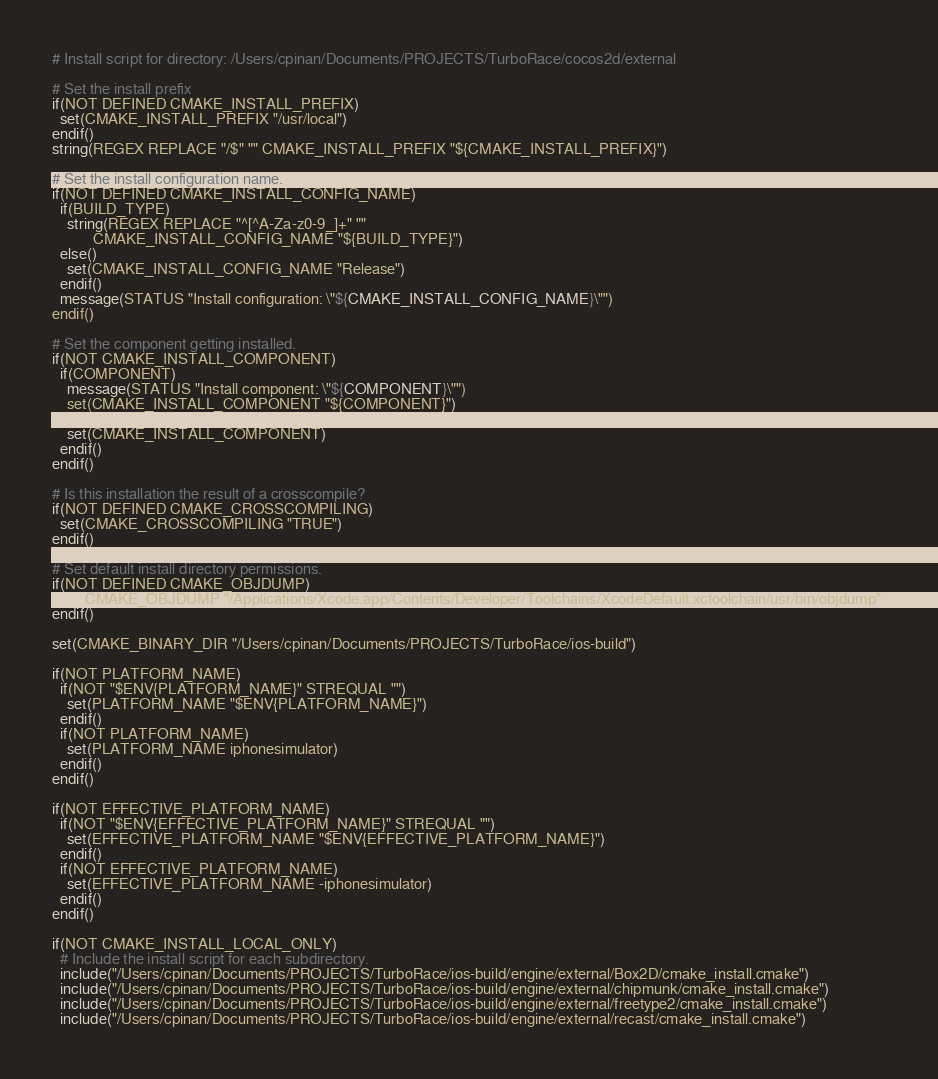Convert code to text. <code><loc_0><loc_0><loc_500><loc_500><_CMake_># Install script for directory: /Users/cpinan/Documents/PROJECTS/TurboRace/cocos2d/external

# Set the install prefix
if(NOT DEFINED CMAKE_INSTALL_PREFIX)
  set(CMAKE_INSTALL_PREFIX "/usr/local")
endif()
string(REGEX REPLACE "/$" "" CMAKE_INSTALL_PREFIX "${CMAKE_INSTALL_PREFIX}")

# Set the install configuration name.
if(NOT DEFINED CMAKE_INSTALL_CONFIG_NAME)
  if(BUILD_TYPE)
    string(REGEX REPLACE "^[^A-Za-z0-9_]+" ""
           CMAKE_INSTALL_CONFIG_NAME "${BUILD_TYPE}")
  else()
    set(CMAKE_INSTALL_CONFIG_NAME "Release")
  endif()
  message(STATUS "Install configuration: \"${CMAKE_INSTALL_CONFIG_NAME}\"")
endif()

# Set the component getting installed.
if(NOT CMAKE_INSTALL_COMPONENT)
  if(COMPONENT)
    message(STATUS "Install component: \"${COMPONENT}\"")
    set(CMAKE_INSTALL_COMPONENT "${COMPONENT}")
  else()
    set(CMAKE_INSTALL_COMPONENT)
  endif()
endif()

# Is this installation the result of a crosscompile?
if(NOT DEFINED CMAKE_CROSSCOMPILING)
  set(CMAKE_CROSSCOMPILING "TRUE")
endif()

# Set default install directory permissions.
if(NOT DEFINED CMAKE_OBJDUMP)
  set(CMAKE_OBJDUMP "/Applications/Xcode.app/Contents/Developer/Toolchains/XcodeDefault.xctoolchain/usr/bin/objdump")
endif()

set(CMAKE_BINARY_DIR "/Users/cpinan/Documents/PROJECTS/TurboRace/ios-build")

if(NOT PLATFORM_NAME)
  if(NOT "$ENV{PLATFORM_NAME}" STREQUAL "")
    set(PLATFORM_NAME "$ENV{PLATFORM_NAME}")
  endif()
  if(NOT PLATFORM_NAME)
    set(PLATFORM_NAME iphonesimulator)
  endif()
endif()

if(NOT EFFECTIVE_PLATFORM_NAME)
  if(NOT "$ENV{EFFECTIVE_PLATFORM_NAME}" STREQUAL "")
    set(EFFECTIVE_PLATFORM_NAME "$ENV{EFFECTIVE_PLATFORM_NAME}")
  endif()
  if(NOT EFFECTIVE_PLATFORM_NAME)
    set(EFFECTIVE_PLATFORM_NAME -iphonesimulator)
  endif()
endif()

if(NOT CMAKE_INSTALL_LOCAL_ONLY)
  # Include the install script for each subdirectory.
  include("/Users/cpinan/Documents/PROJECTS/TurboRace/ios-build/engine/external/Box2D/cmake_install.cmake")
  include("/Users/cpinan/Documents/PROJECTS/TurboRace/ios-build/engine/external/chipmunk/cmake_install.cmake")
  include("/Users/cpinan/Documents/PROJECTS/TurboRace/ios-build/engine/external/freetype2/cmake_install.cmake")
  include("/Users/cpinan/Documents/PROJECTS/TurboRace/ios-build/engine/external/recast/cmake_install.cmake")</code> 